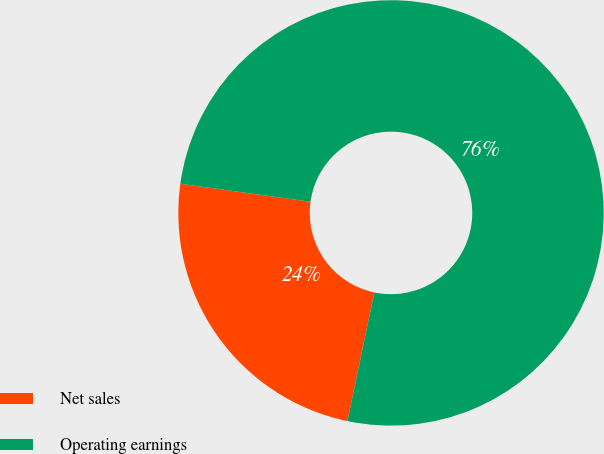Convert chart. <chart><loc_0><loc_0><loc_500><loc_500><pie_chart><fcel>Net sales<fcel>Operating earnings<nl><fcel>23.91%<fcel>76.09%<nl></chart> 